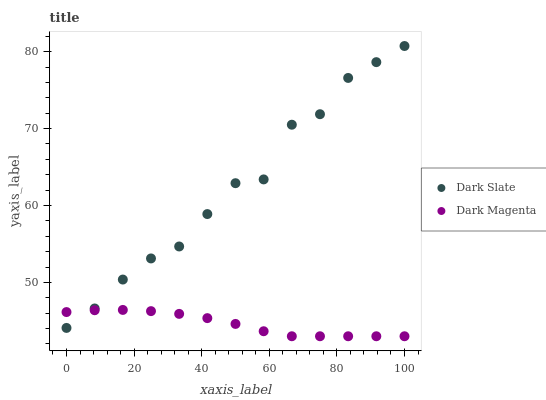Does Dark Magenta have the minimum area under the curve?
Answer yes or no. Yes. Does Dark Slate have the maximum area under the curve?
Answer yes or no. Yes. Does Dark Magenta have the maximum area under the curve?
Answer yes or no. No. Is Dark Magenta the smoothest?
Answer yes or no. Yes. Is Dark Slate the roughest?
Answer yes or no. Yes. Is Dark Magenta the roughest?
Answer yes or no. No. Does Dark Magenta have the lowest value?
Answer yes or no. Yes. Does Dark Slate have the highest value?
Answer yes or no. Yes. Does Dark Magenta have the highest value?
Answer yes or no. No. Does Dark Slate intersect Dark Magenta?
Answer yes or no. Yes. Is Dark Slate less than Dark Magenta?
Answer yes or no. No. Is Dark Slate greater than Dark Magenta?
Answer yes or no. No. 